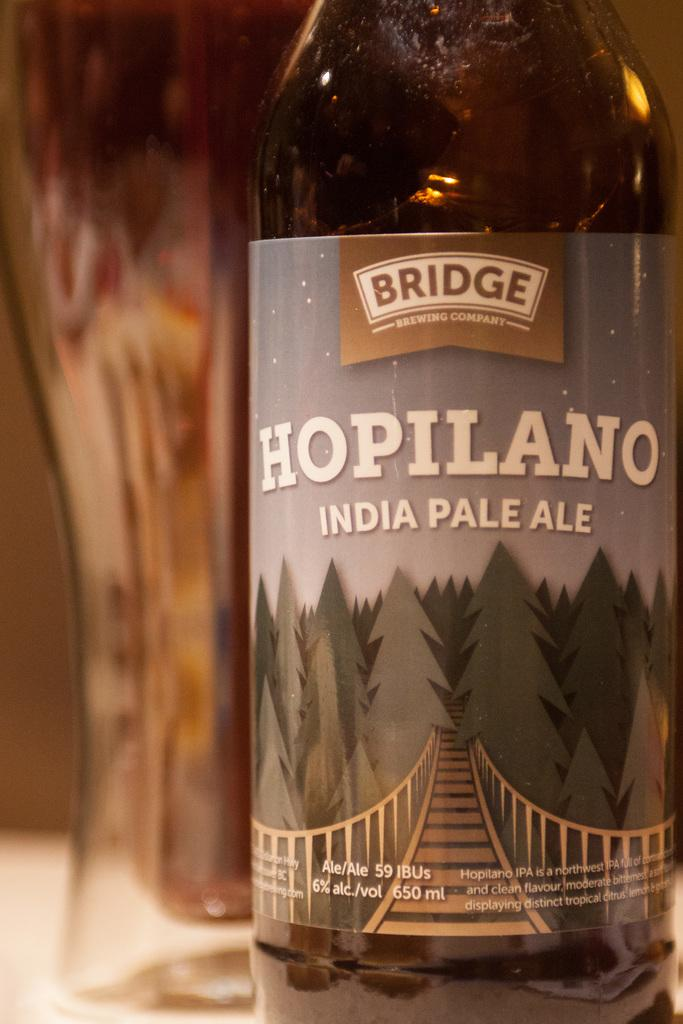What is the main object in the image? There is a wine bottle in the image. Can you describe the color of the wine bottle? The wine bottle is black in color. What type of dogs can be seen barking during the thunderstorm in the image? There are no dogs or thunderstorm present in the image; it only features a black wine bottle. 